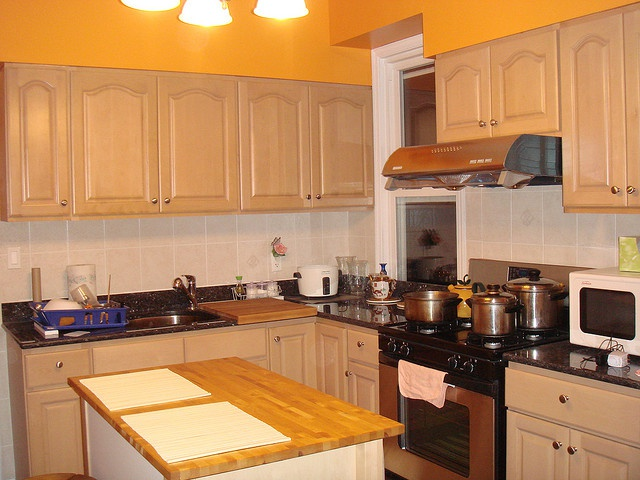Describe the objects in this image and their specific colors. I can see dining table in orange, khaki, and tan tones, oven in orange, black, maroon, tan, and brown tones, microwave in orange, black, tan, maroon, and lightgray tones, bowl in orange, maroon, black, and gray tones, and sink in orange, black, maroon, and gray tones in this image. 